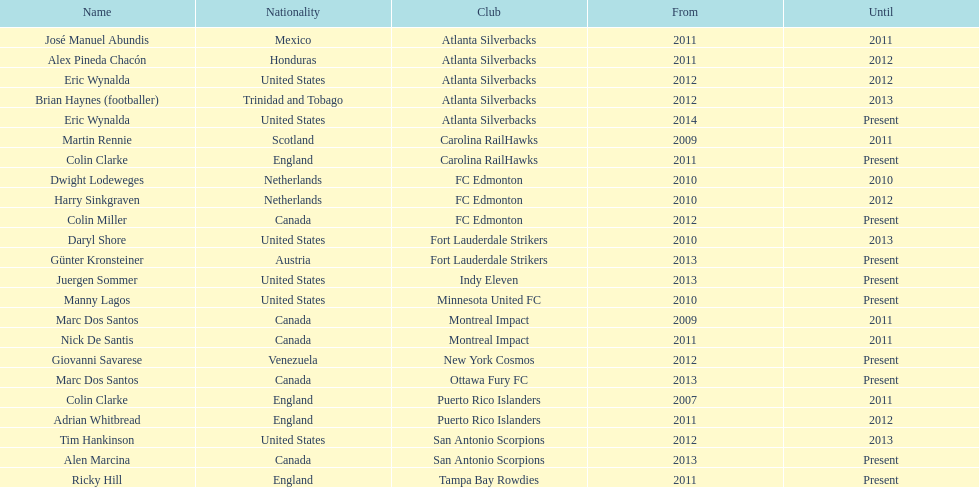Between abundis and chacon, who had a longer coaching tenure with the silverbacks? Chacon. 